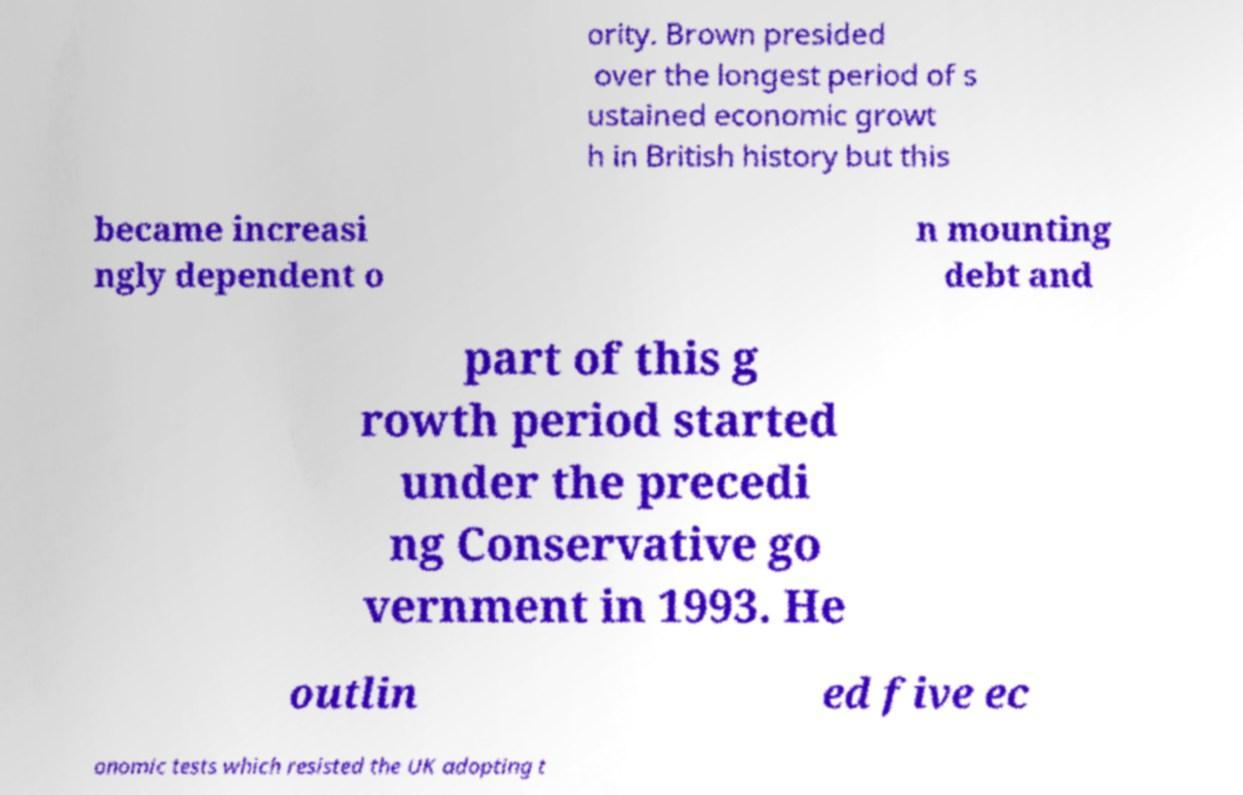Can you accurately transcribe the text from the provided image for me? ority. Brown presided over the longest period of s ustained economic growt h in British history but this became increasi ngly dependent o n mounting debt and part of this g rowth period started under the precedi ng Conservative go vernment in 1993. He outlin ed five ec onomic tests which resisted the UK adopting t 